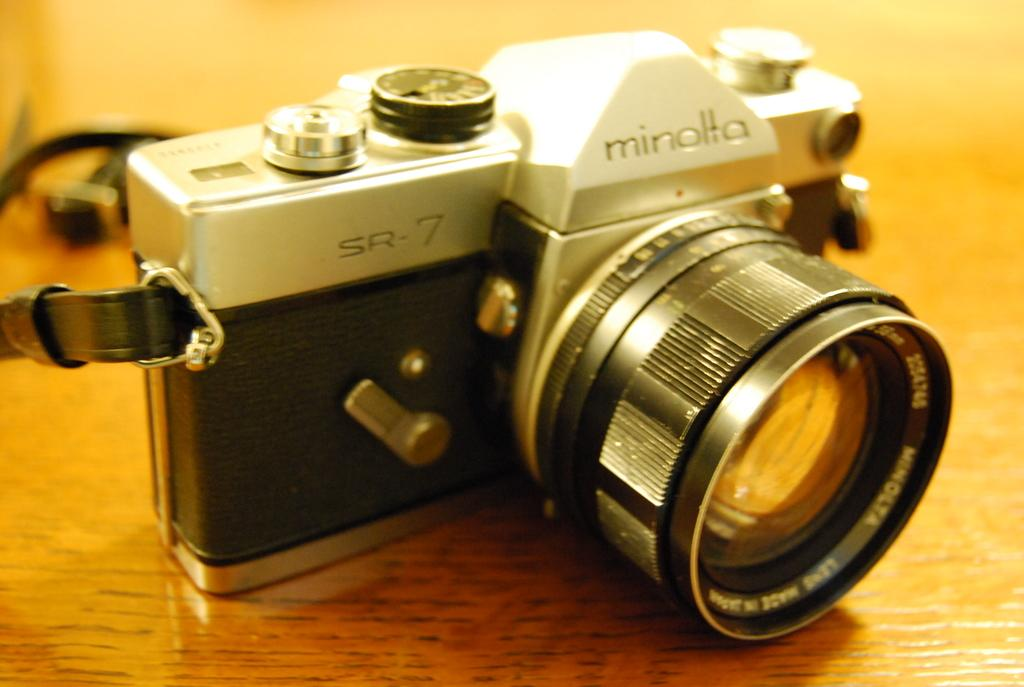What object is the main subject of the image? There is a camera in the image. Are there any additional details on the camera? Yes, there is writing on the camera. Can you describe the overall quality of the image? The image appears to be blurry. How many pins are visible on the camera in the image? There are no pins visible on the camera in the image. What is the amount of crush that can be seen in the image? There is no crush present in the image; it features a camera with writing on it. 